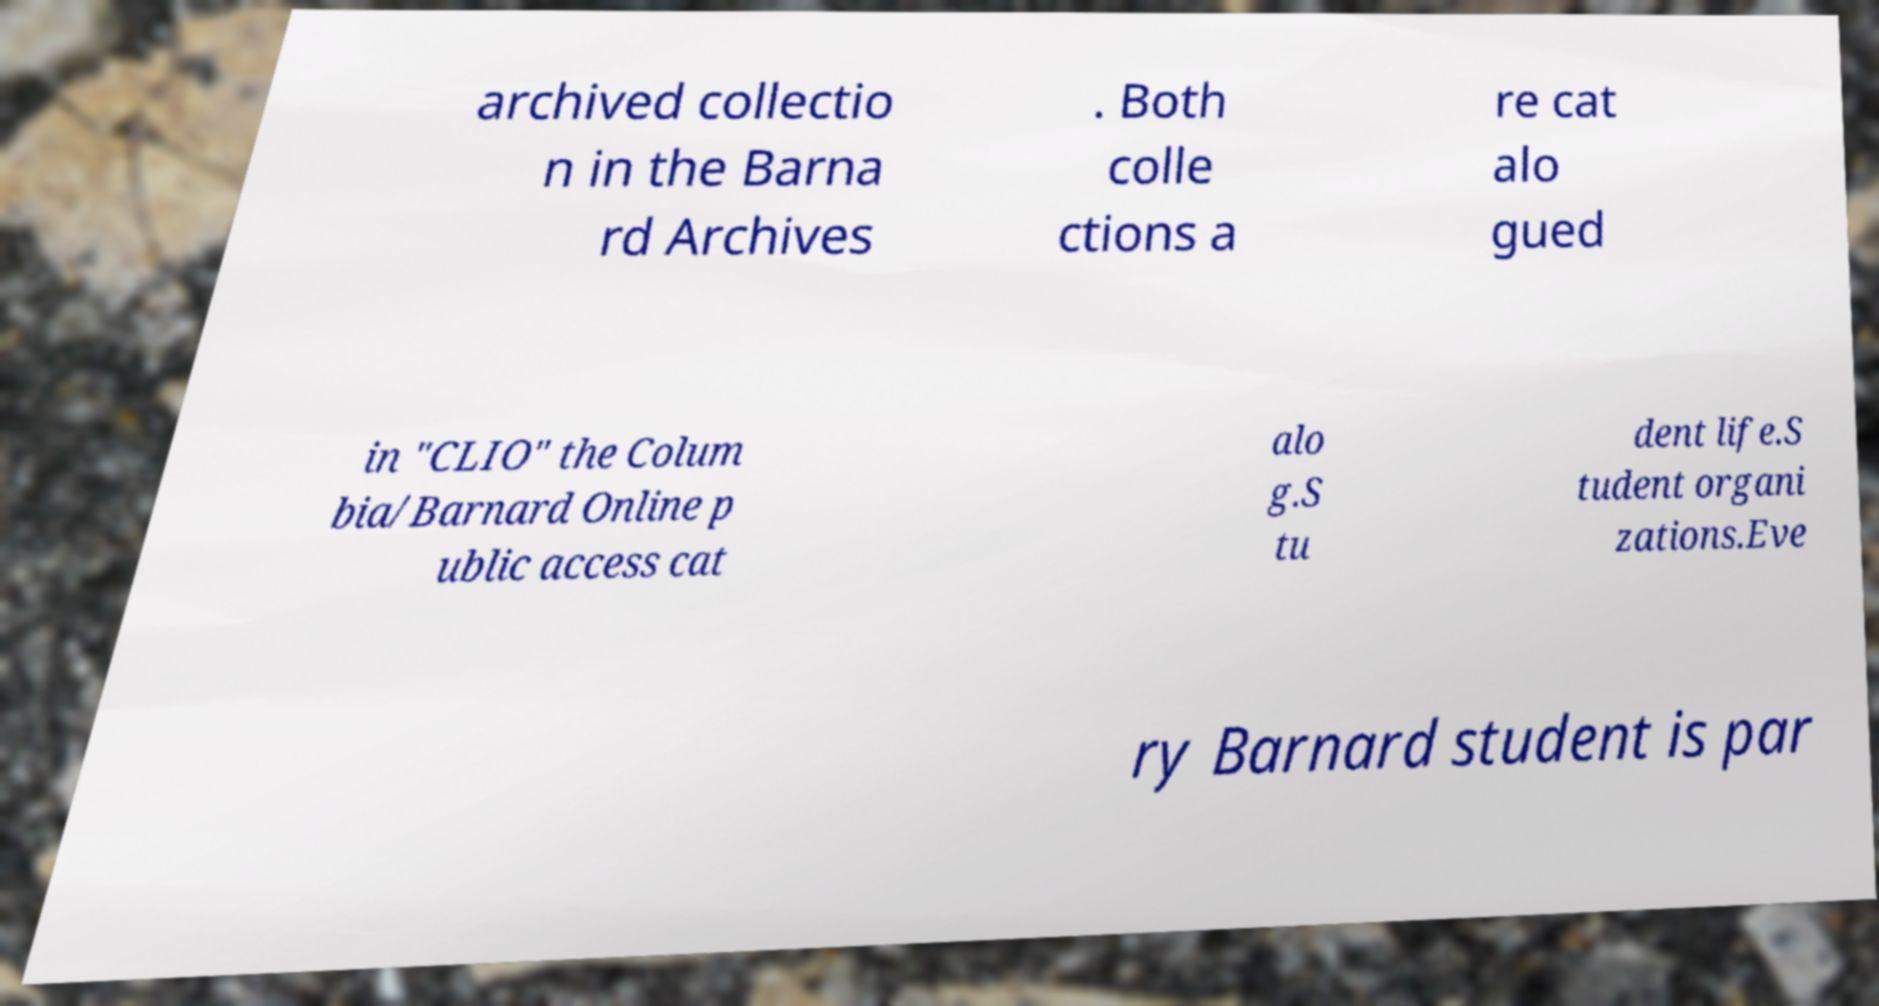Could you extract and type out the text from this image? archived collectio n in the Barna rd Archives . Both colle ctions a re cat alo gued in "CLIO" the Colum bia/Barnard Online p ublic access cat alo g.S tu dent life.S tudent organi zations.Eve ry Barnard student is par 